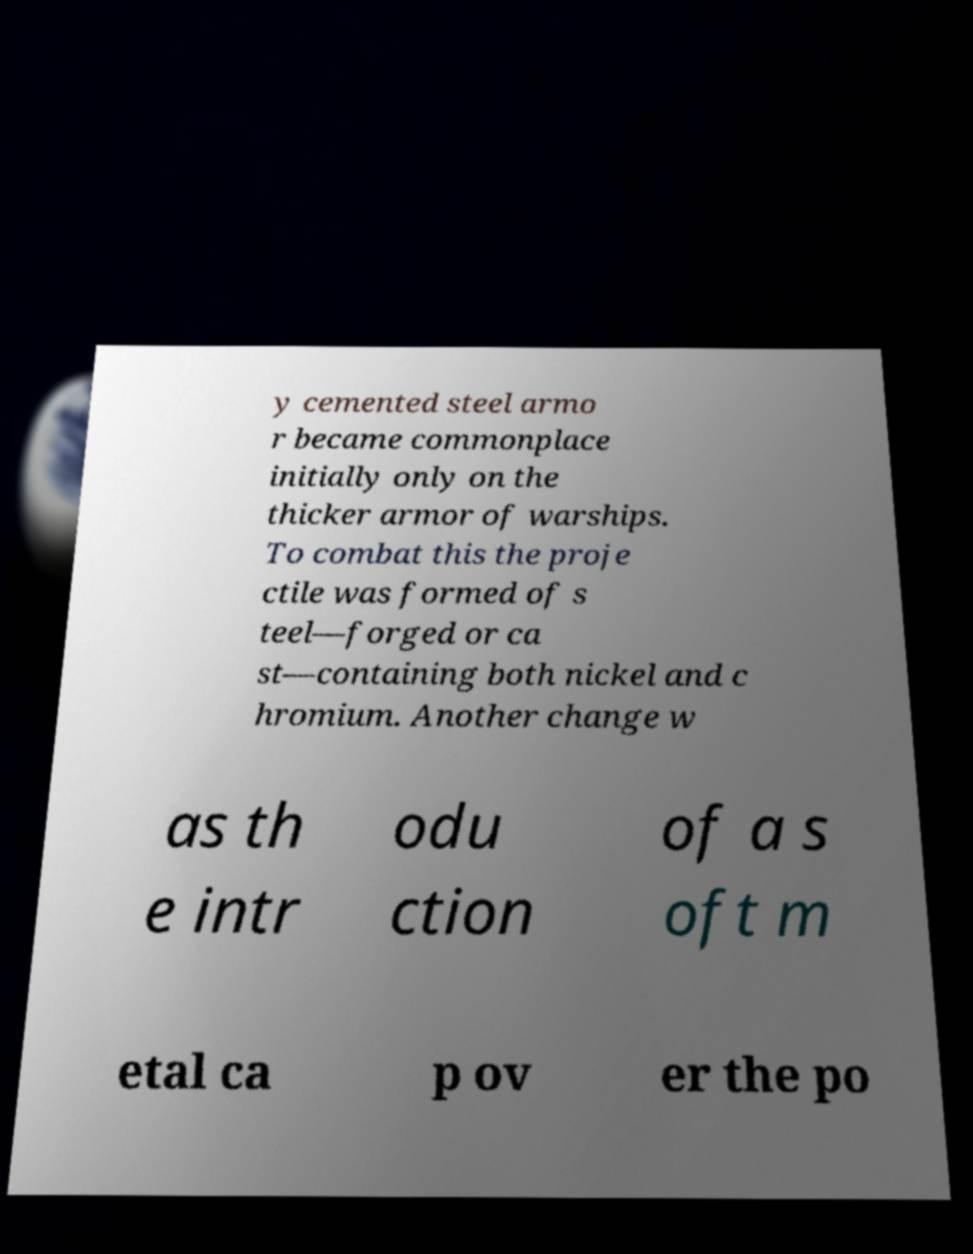I need the written content from this picture converted into text. Can you do that? y cemented steel armo r became commonplace initially only on the thicker armor of warships. To combat this the proje ctile was formed of s teel—forged or ca st—containing both nickel and c hromium. Another change w as th e intr odu ction of a s oft m etal ca p ov er the po 